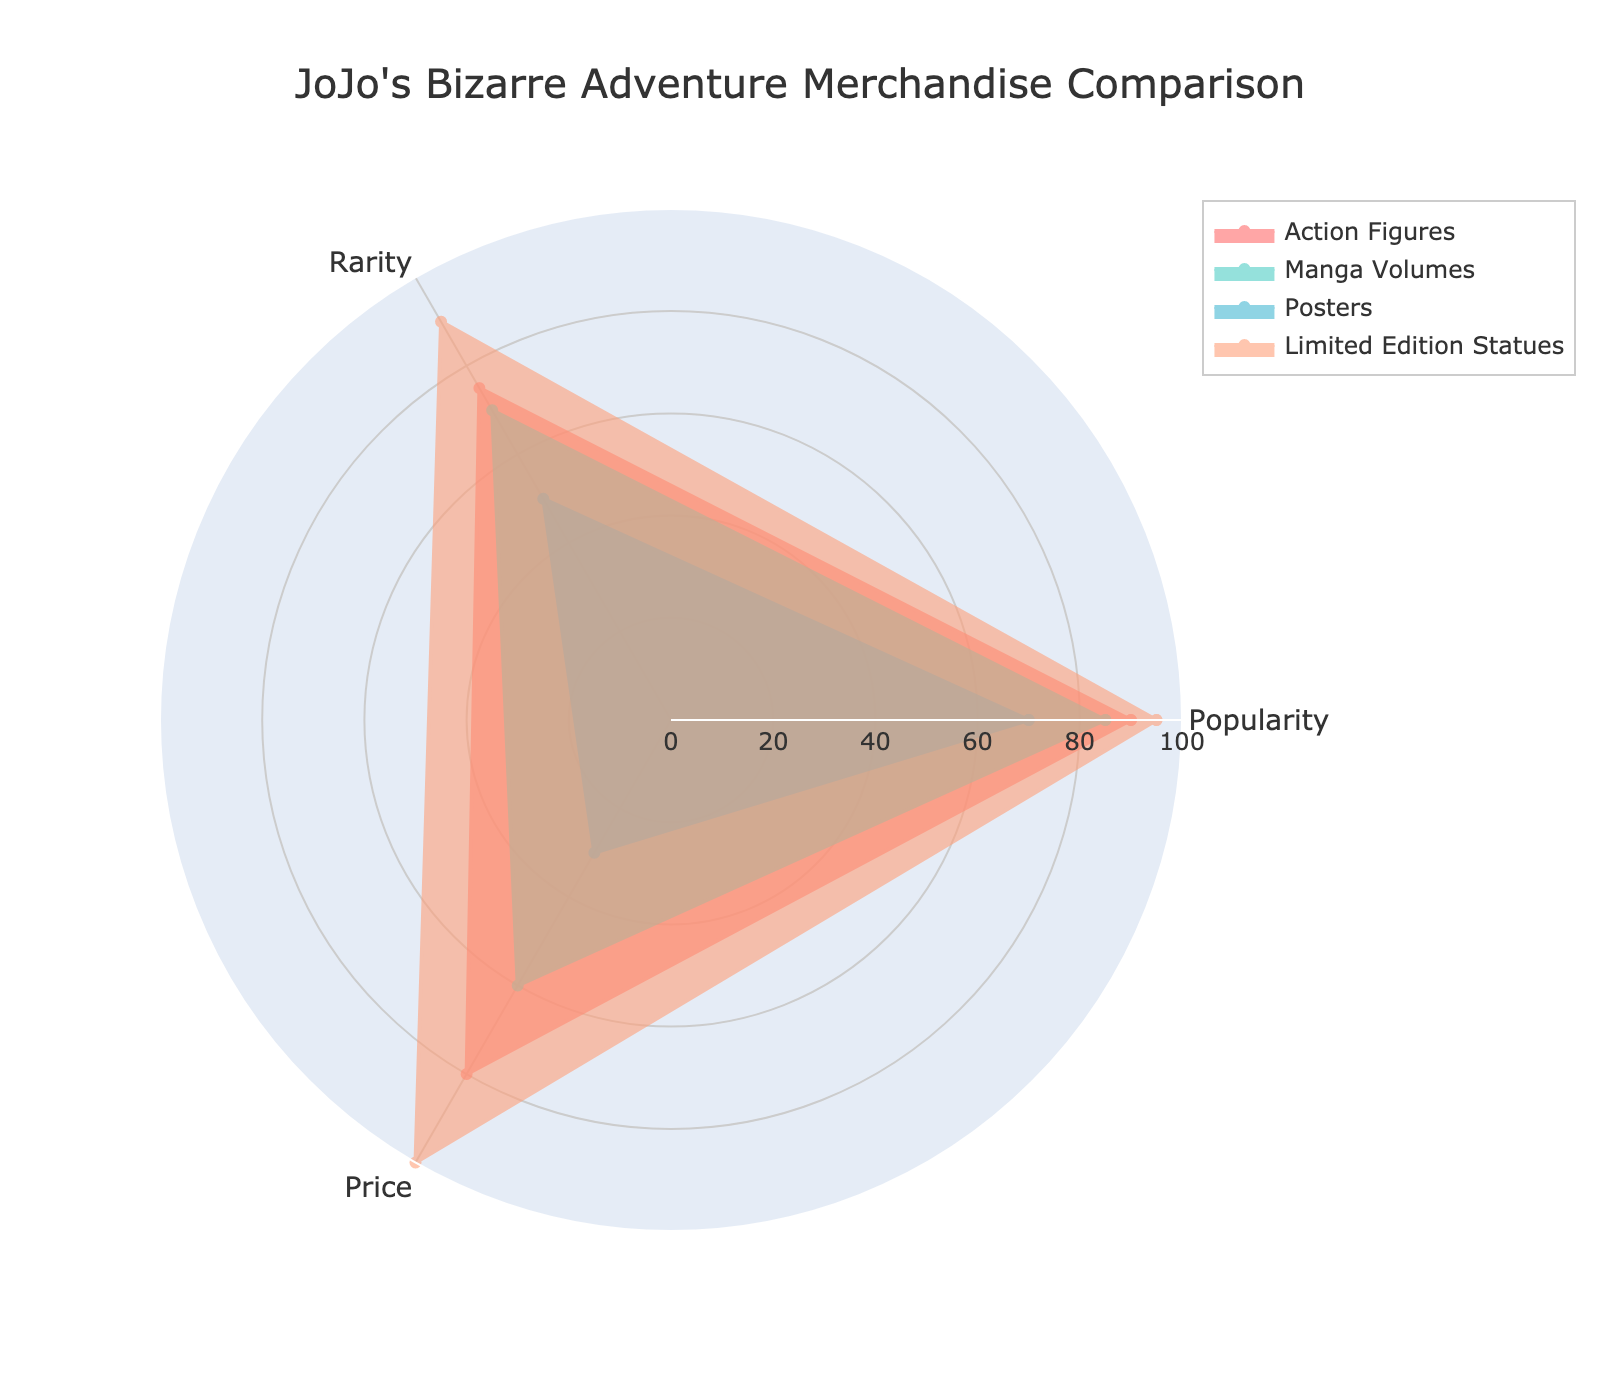What is the most expensive category of merchandise? The radar chart shows the price of each category on one of its axes. The category with the highest value on this axis is the most expensive. The "Limited Edition Statues" category reaches a value of 100, which is the highest.
Answer: Limited Edition Statues Which category has the lowest popularity? By inspecting the popularity axis on the radar chart, look for the category with the smallest value. The "Posters" category shows a value of 70, which is the lowest among all categories.
Answer: Posters How does the rarity of action figures compare to manga volumes? On the radar chart, find the values for rarity of both categories. "Action Figures" have a rarity value of 75, whereas "Manga Volumes" have a rarity value of 70. Thus, action figures are slightly rarer.
Answer: Action Figures are rarer Which two categories have the closest price values? By looking at the price axis for all categories, identify the two categories with the most similar values. Both "Action Figures" and "Manga Volumes" have relatively close values of 80 and 60 respectively. Although not identical, they are closer to each other than other pairs.
Answer: Action Figures and Manga Volumes What are the three measured attributes of the merchandise? The radar chart displays three main attributes, with each axis representing one. These attributes are "Popularity," "Rarity," and "Price."
Answer: Popularity, Rarity, Price Is there any category that is highest in all three attributes? Check each axis for the highest values and see if any single category is the highest in all of them. "Limited Edition Statues" has the highest values for rarity (90) and price (100) but not for popularity, indicating no category is the highest in all three attributes.
Answer: No Which attribute shows the largest difference between the lowest and highest values across all categories? Calculate the range for each attribute across categories: 
- Popularity ranges from 70 (Posters) to 95 (Limited Edition Statues) = 25
- Rarity ranges from 50 (Posters) to 90 (Limited Edition Statues) = 40
- Price ranges from 30 (Posters) to 100 (Limited Edition Statues) = 70
The largest difference is observed in the "Price" attribute.
Answer: Price If we average the rarity and price for "Action Figures," how does this average compare to their popularity? The values are rarity = 75 and price = 80. The average is (75 + 80) / 2 = 77.5. The popularity of "Action Figures" is 90. Comparing these two, the average rarity and price (77.5) is less than their popularity (90).
Answer: Less than their popularity Which category has the highest overall values considering all attributes combined? Sum the values of each attribute for every category:
- Action Figures: 90 + 75 + 80 = 245
- Manga Volumes: 85 + 70 + 60 = 215
- Posters: 70 + 50 + 30 = 150
- Limited Edition Statues: 95 + 90 + 100 = 285
"Limited Edition Statues" has the highest combined value.
Answer: Limited Edition Statues What color is used for the "Manga Volumes" category in the chart? This can be identified by noting the color coding used in the radar chart legend. "Manga Volumes" is represented by the color hex #4ECDC4, which corresponds to a shade of green.
Answer: Green 